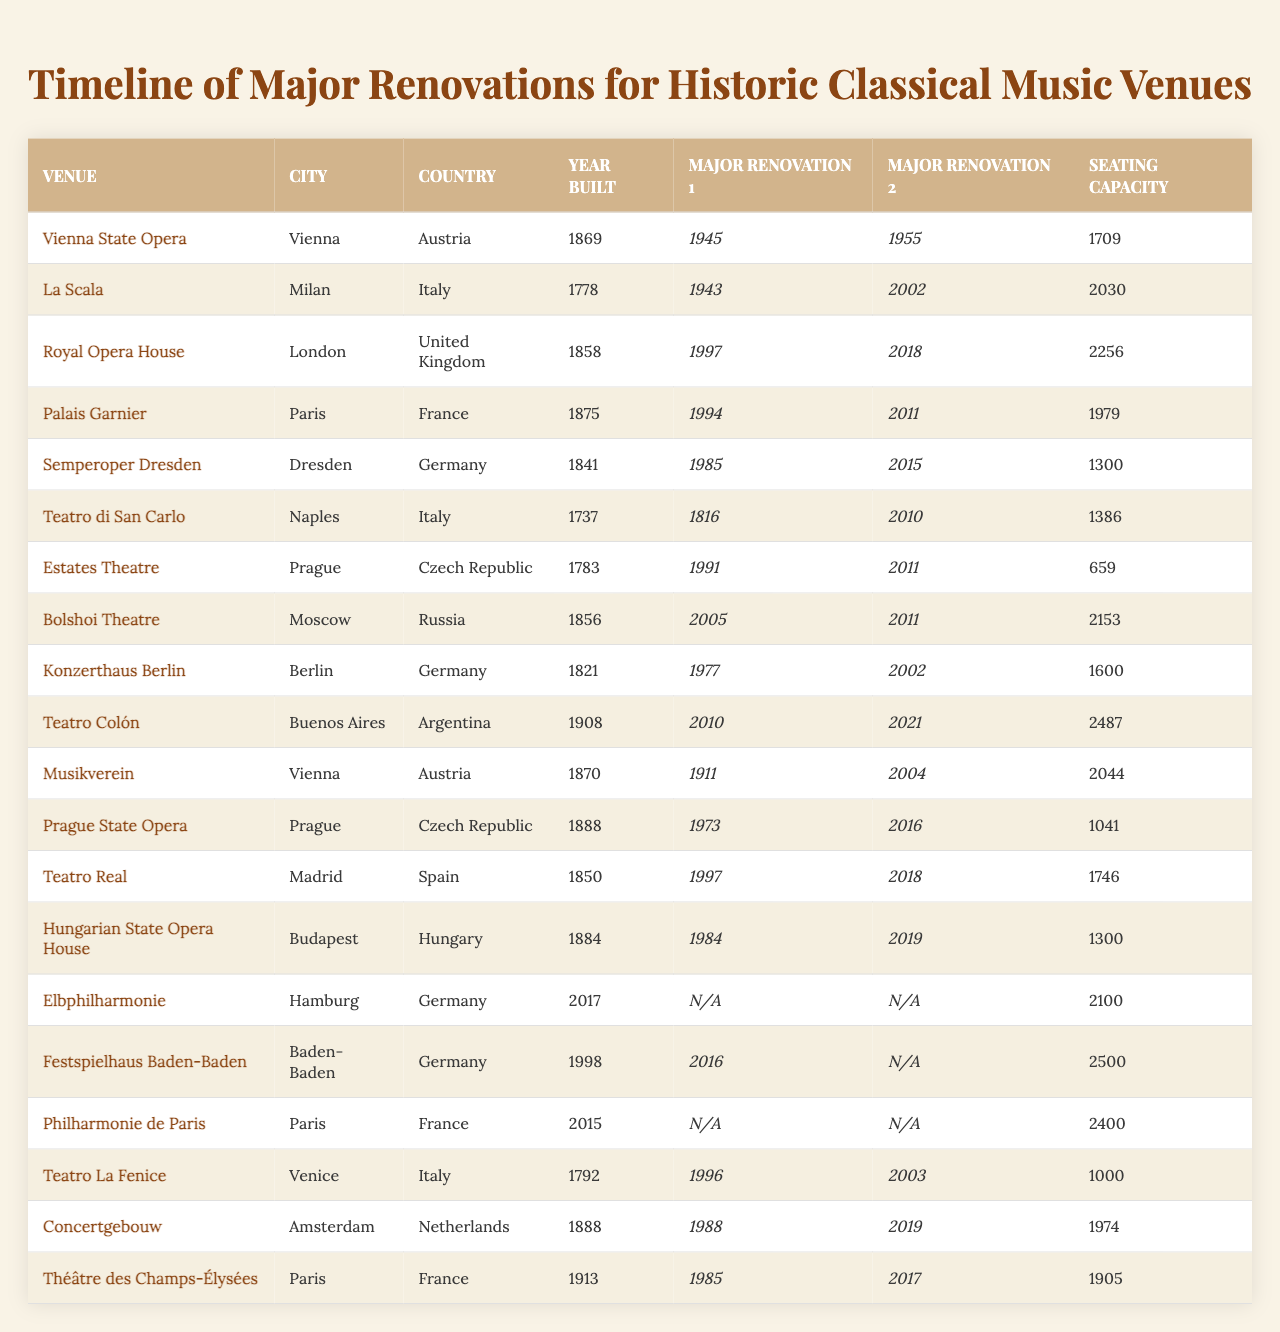What year was the Vienna State Opera built? The table lists the year built for each venue. For the Vienna State Opera, the corresponding year is 1869.
Answer: 1869 Which venue has the largest seating capacity? The seating capacities are listed in the table; the largest number is 2487 for Teatro Colón.
Answer: 2487 What were the major renovation years for La Scala? The table shows that La Scala underwent major renovations in 1943 and 2002.
Answer: 1943 and 2002 Did the Royal Opera House have a renovation in 1997? Checking the table, the Royal Opera House lists its first major renovation as 1997, which confirms the fact.
Answer: Yes What is the average year of the major renovations for Palais Garnier? The years of major renovations are 1994 and 2011. Summing them: 1994 + 2011 = 4005, then dividing by 2 gives an average year of 2002.5 (or rounded to 2003).
Answer: 2003 Which city has the most venues listed in the table? Analyzing the city column, Vienna appears twice, while other cities have only one entry each.
Answer: Vienna Was there a major renovation for the Semperoper Dresden in 2015? The table shows that Semperoper Dresden had major renovations in 1985 and 2015, confirming that it did indeed have a renovation in 2015.
Answer: Yes How many venues were built before 1800? By examining the Year Built column, the venues built before 1800 are La Scala (1778), Teatro di San Carlo (1737), Estates Theatre (1783), and Théâtre des Champs-Élysées (1792). This totals to four venues.
Answer: 4 What is the renovation gap for Bolshoi Theatre between its two major renovations? The table shows renovations in 2005 and 2011. Calculating the difference gives: 2011 - 2005 = 6 years.
Answer: 6 years Which venue was built most recently, and when was it constructed? The table reveals that the Elbphilharmonie was the most recently built venue in 2017.
Answer: Elbphilharmonie, 2017 How many venues have undergone renovations in the year 2018? Referring to the table, Teatro Real and Royal Opera House both had major renovations in 2018, totaling two venues.
Answer: 2 